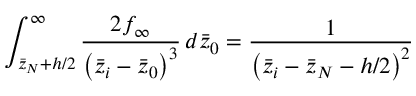<formula> <loc_0><loc_0><loc_500><loc_500>\int _ { \bar { z } _ { N } + h / 2 } ^ { \infty } \frac { 2 f _ { \infty } } { \left ( \bar { z } _ { i } - \bar { z } _ { 0 } \right ) ^ { 3 } } \, d \bar { z } _ { 0 } = \frac { 1 } { \left ( \bar { z } _ { i } - \bar { z } _ { N } - h / 2 \right ) ^ { 2 } }</formula> 